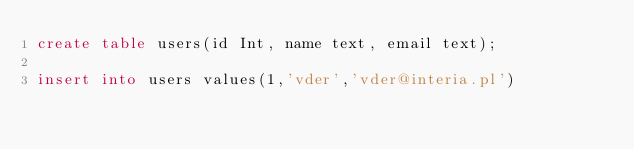Convert code to text. <code><loc_0><loc_0><loc_500><loc_500><_SQL_>create table users(id Int, name text, email text);

insert into users values(1,'vder','vder@interia.pl')</code> 